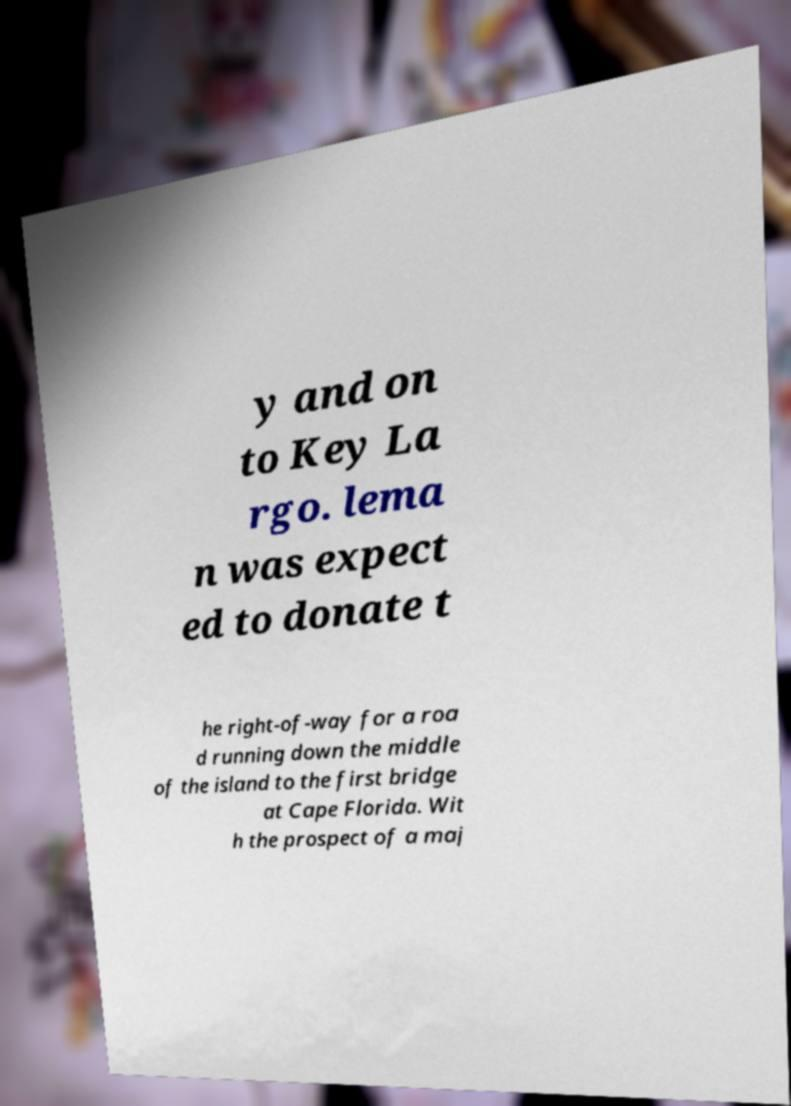Please identify and transcribe the text found in this image. y and on to Key La rgo. lema n was expect ed to donate t he right-of-way for a roa d running down the middle of the island to the first bridge at Cape Florida. Wit h the prospect of a maj 